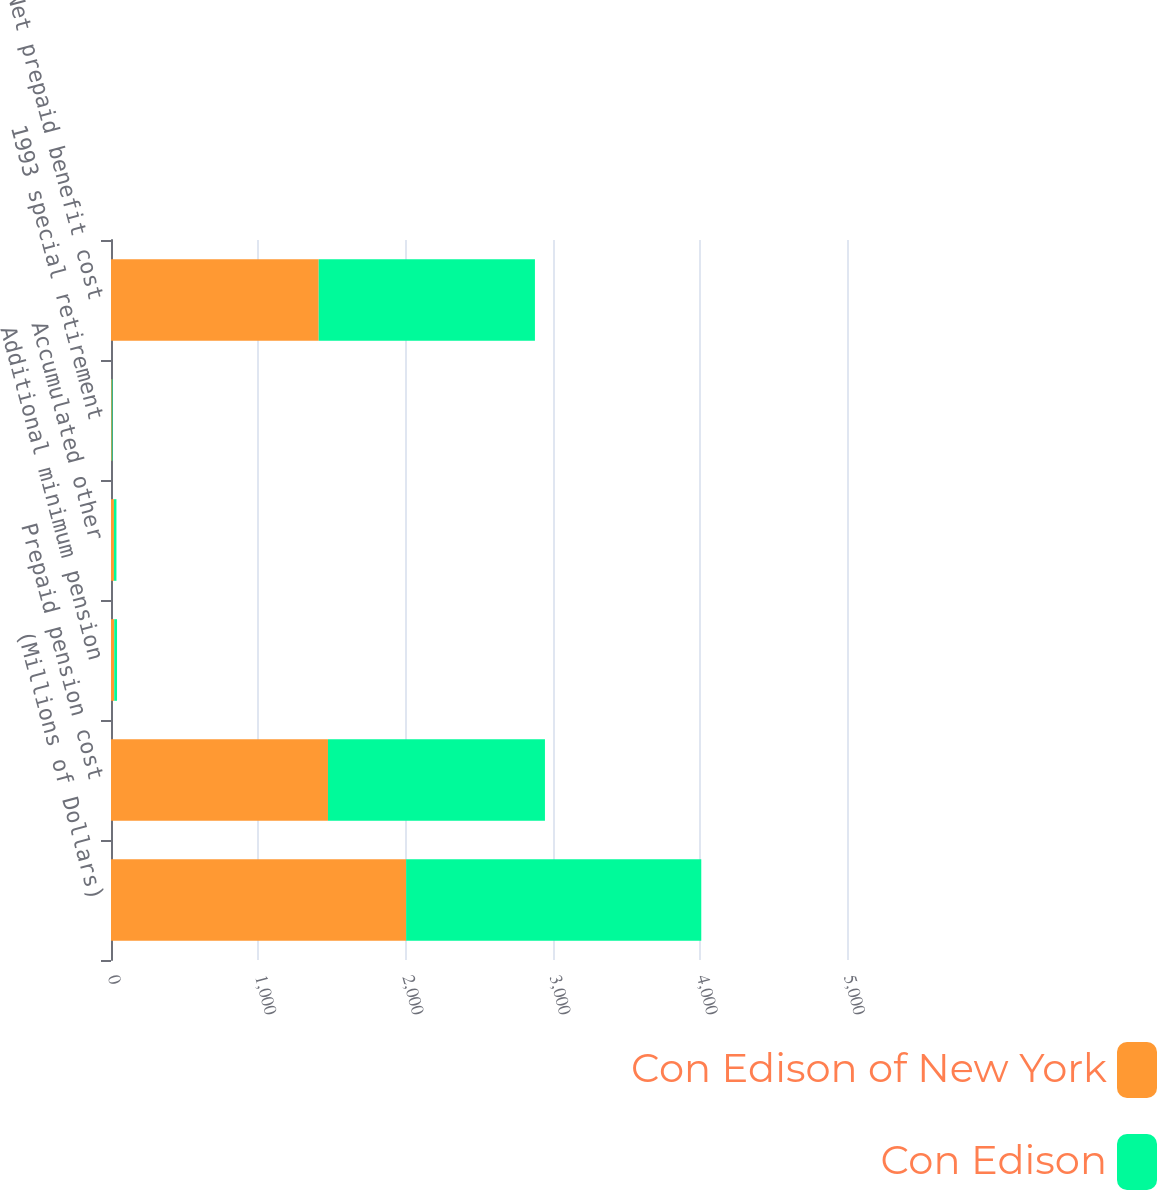<chart> <loc_0><loc_0><loc_500><loc_500><stacked_bar_chart><ecel><fcel>(Millions of Dollars)<fcel>Prepaid pension cost<fcel>Additional minimum pension<fcel>Accumulated other<fcel>1993 special retirement<fcel>Net prepaid benefit cost<nl><fcel>Con Edison of New York<fcel>2005<fcel>1474<fcel>22<fcel>20<fcel>5<fcel>1411<nl><fcel>Con Edison<fcel>2005<fcel>1474<fcel>19<fcel>17<fcel>5<fcel>1469<nl></chart> 